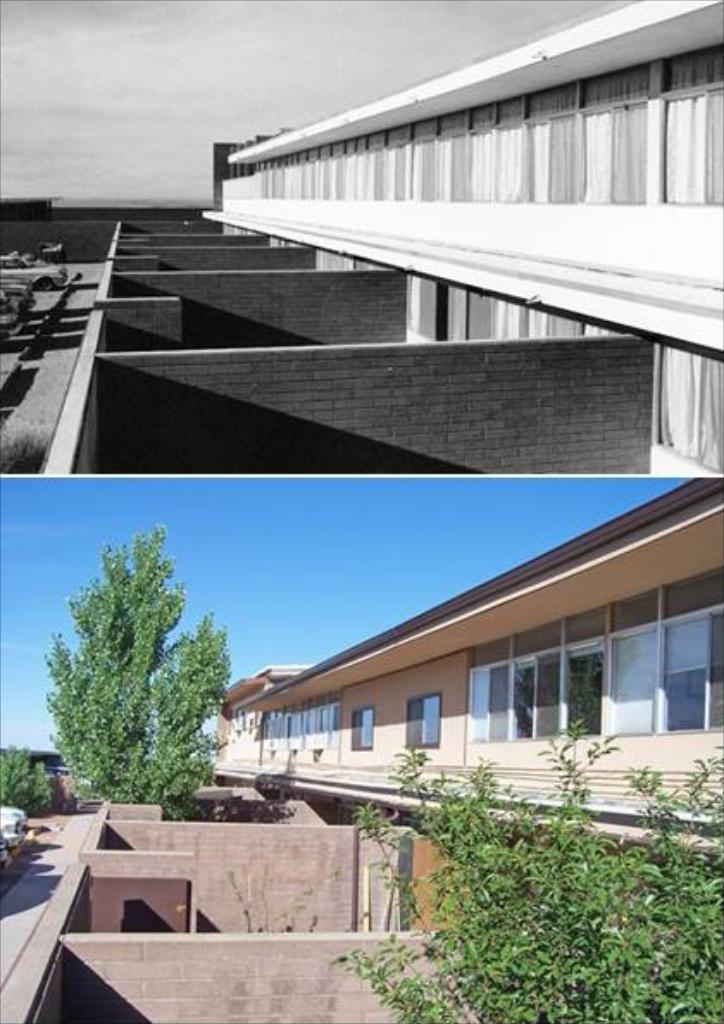What is located in the foreground of the image? There is a building, walls, trees, and cars in the foreground of the image. What is present on top of the image? There is a building, walls, and cars on top of the image. Can you describe the vegetation in the foreground of the image? There are trees in the foreground of the image. What type of prose can be seen written on the walls in the image? There is no prose visible on the walls in the image. What is the cause of the trees growing on top of the image? There is no cause for the trees growing on top of the image, as they are not actually growing there; it is a two-dimensional representation in the image. 